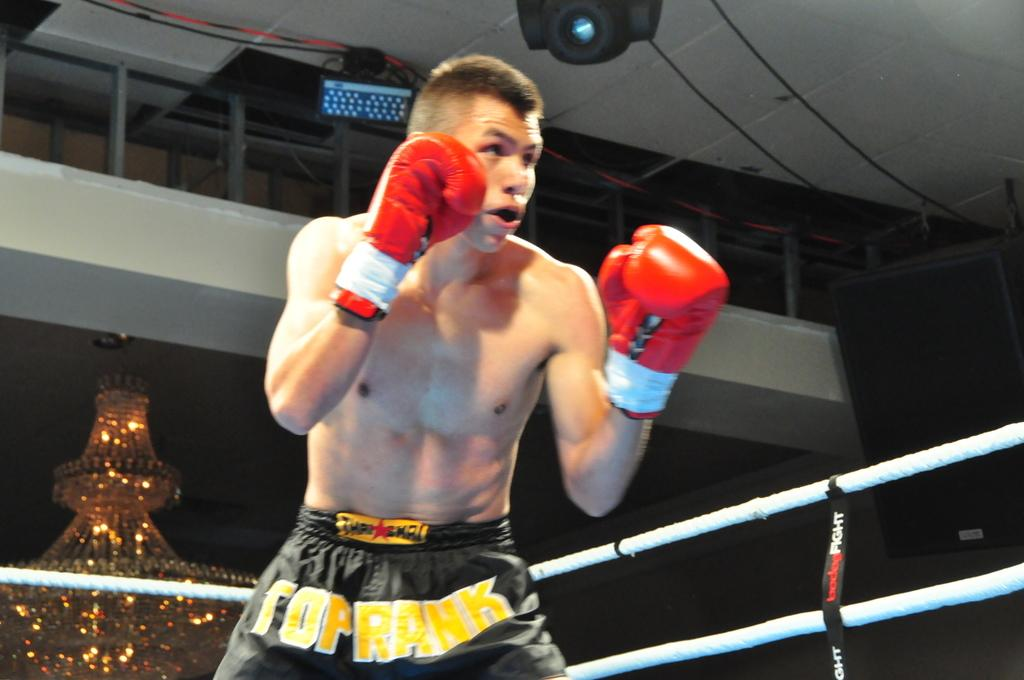What is the man in the image doing? The man is standing in a boxing ring. What type of lighting fixture can be seen in the image? There is a chandelier in the image. What can be seen in the background of the image? There is a speaker visible in the background. What language is the man speaking in the image? There is no indication of the man speaking in the image, so it cannot be determined which language he might be using. 